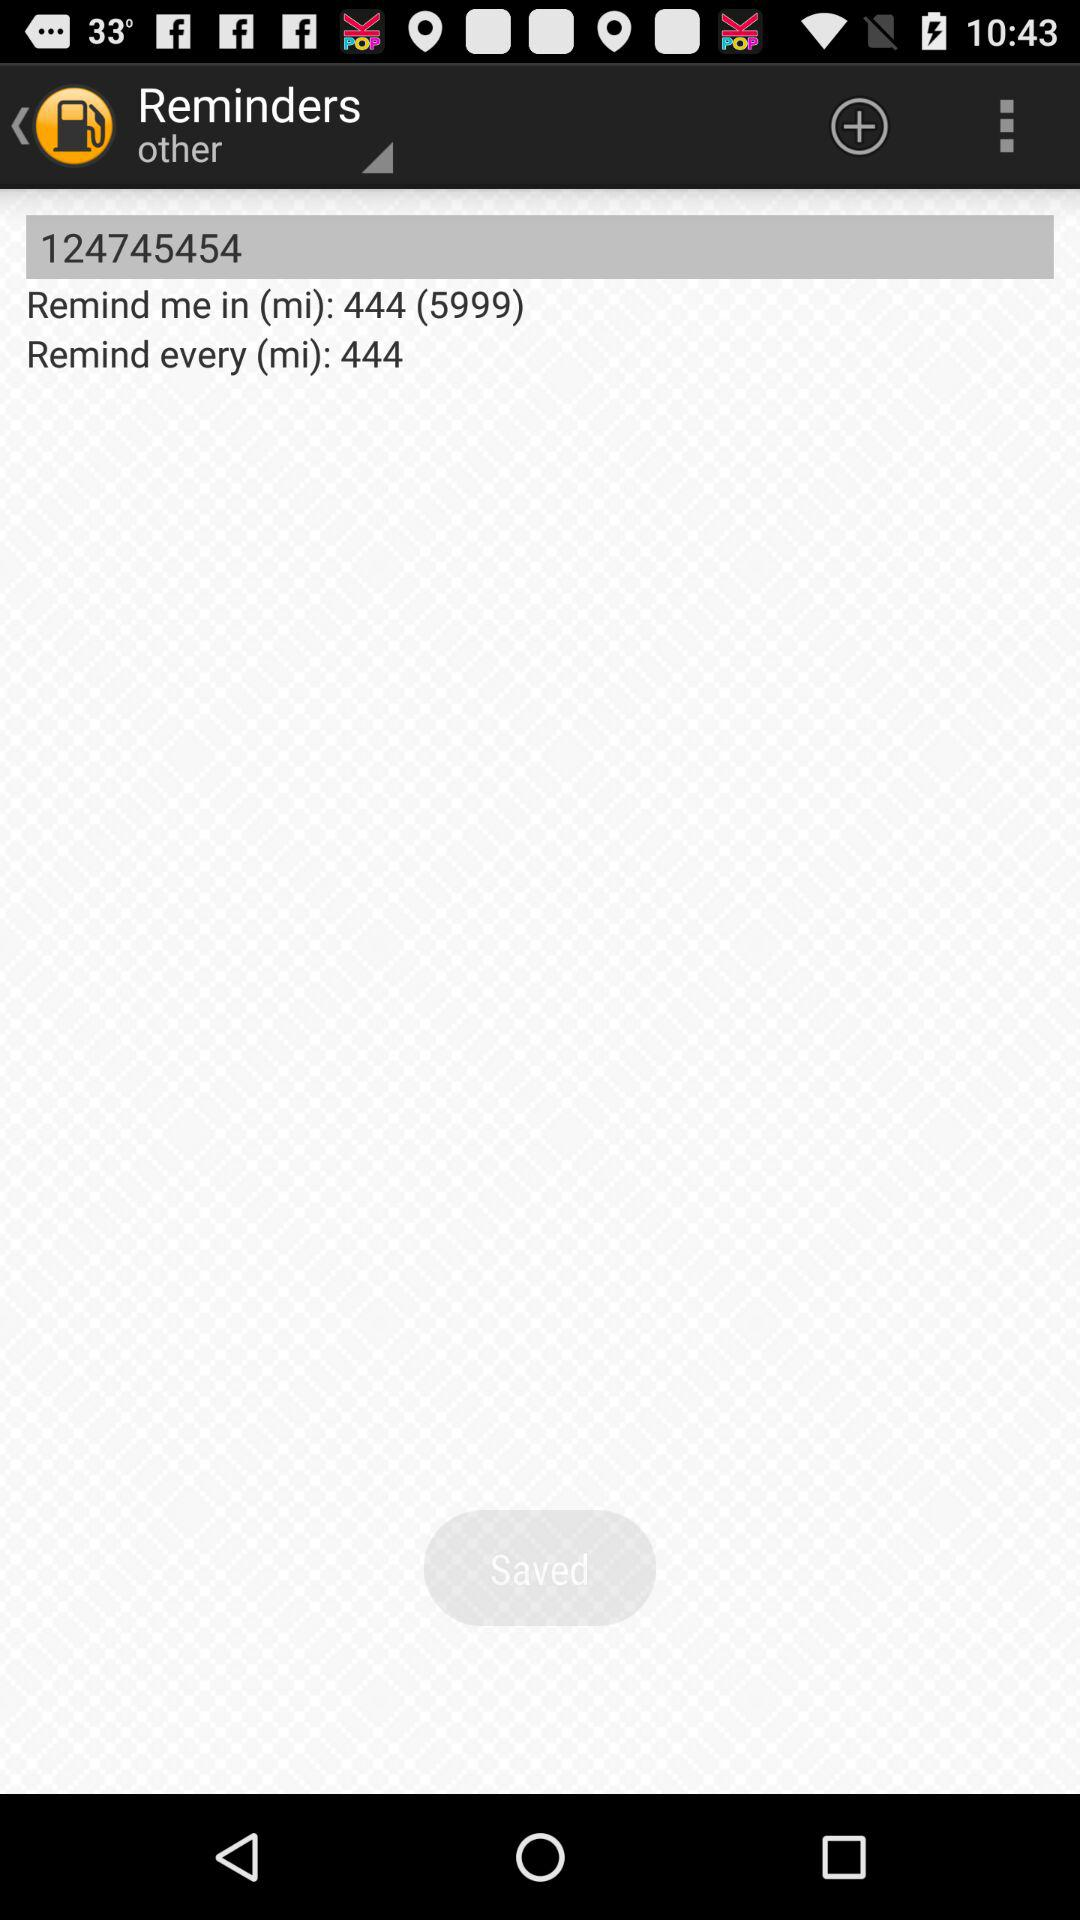After how many miles will the reminder appear? The reminder will appear after 444 miles. 